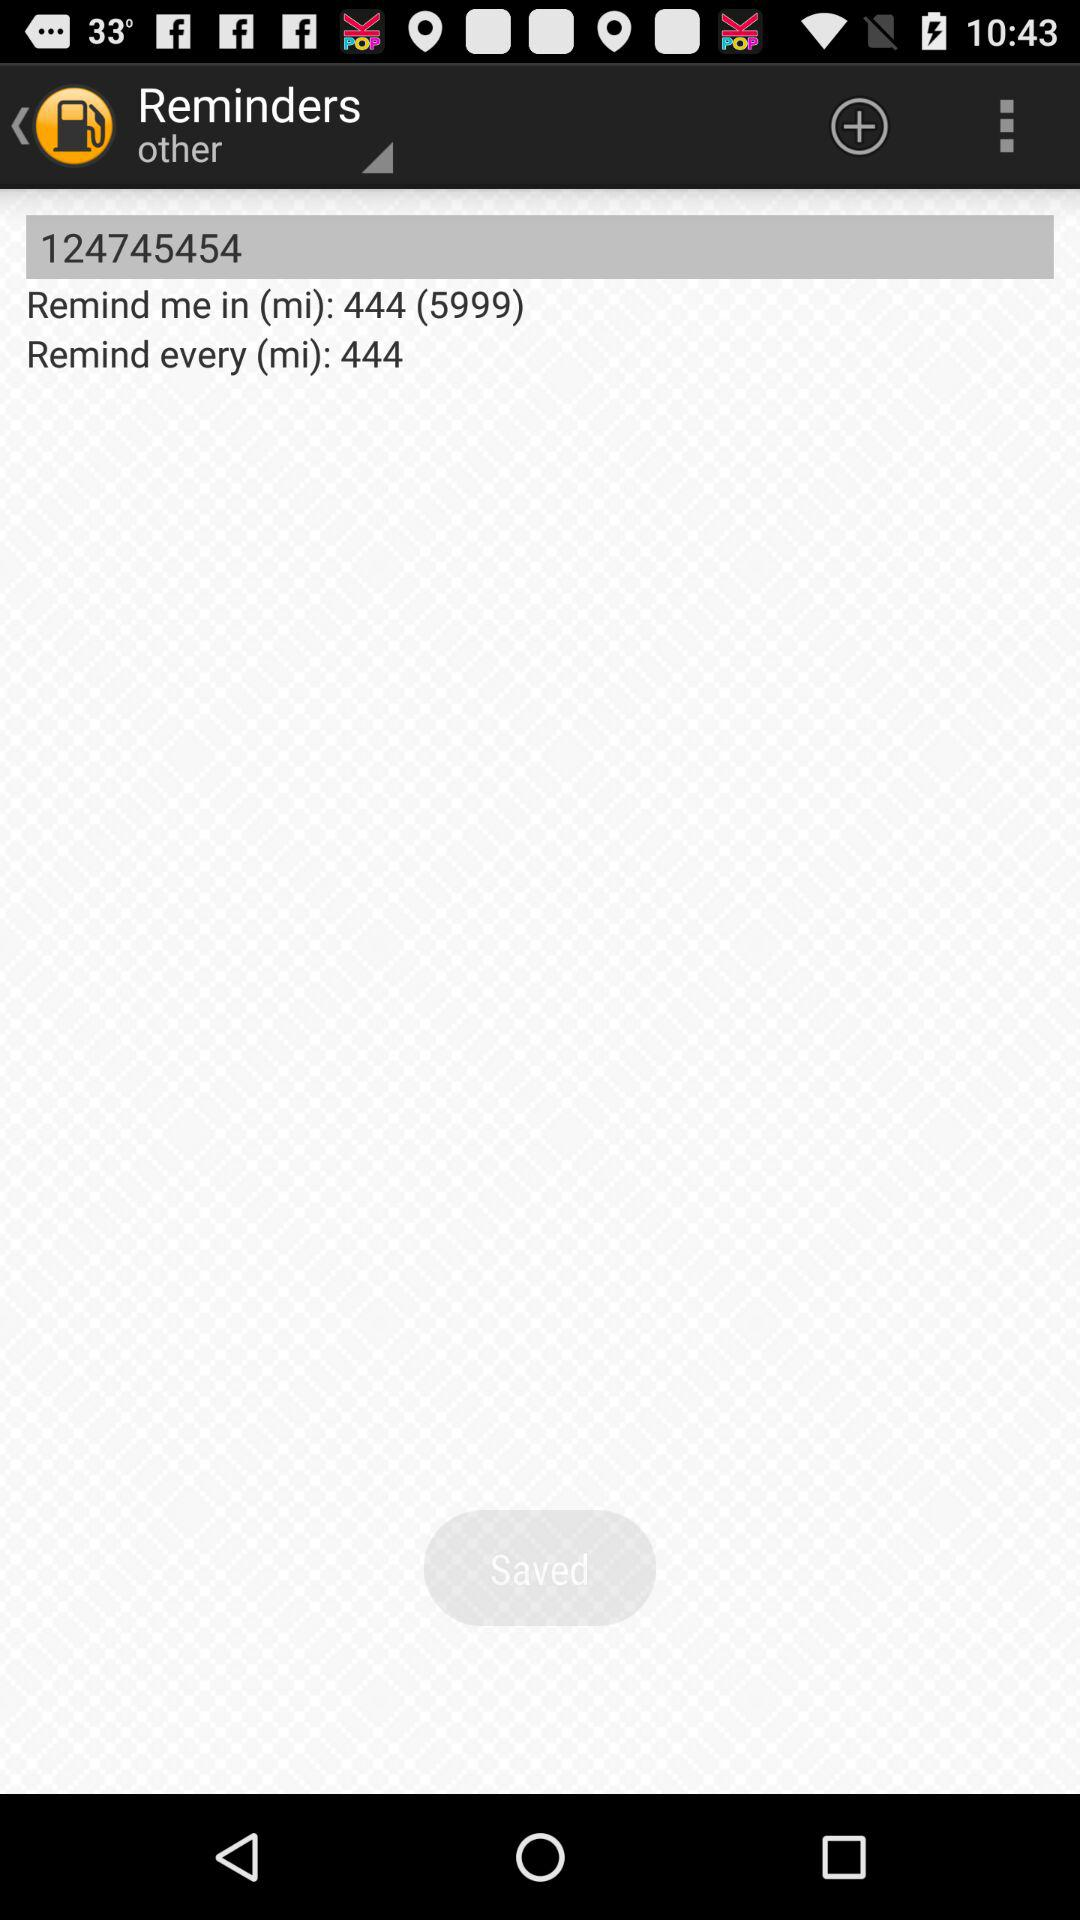After how many miles will the reminder appear? The reminder will appear after 444 miles. 